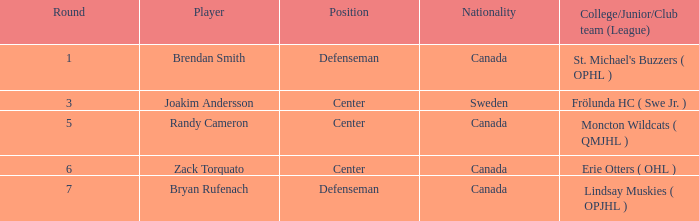In what place was center joakim andersson born? Sweden. 